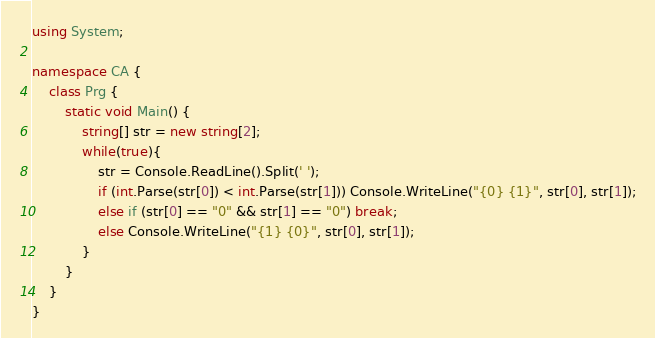<code> <loc_0><loc_0><loc_500><loc_500><_C#_>using System;

namespace CA {
	class Prg {
		static void Main() {
			string[] str = new string[2];
			while(true){
				str = Console.ReadLine().Split(' ');
				if (int.Parse(str[0]) < int.Parse(str[1])) Console.WriteLine("{0} {1}", str[0], str[1]);
				else if (str[0] == "0" && str[1] == "0") break;
				else Console.WriteLine("{1} {0}", str[0], str[1]);
			}
		}
	}
}</code> 